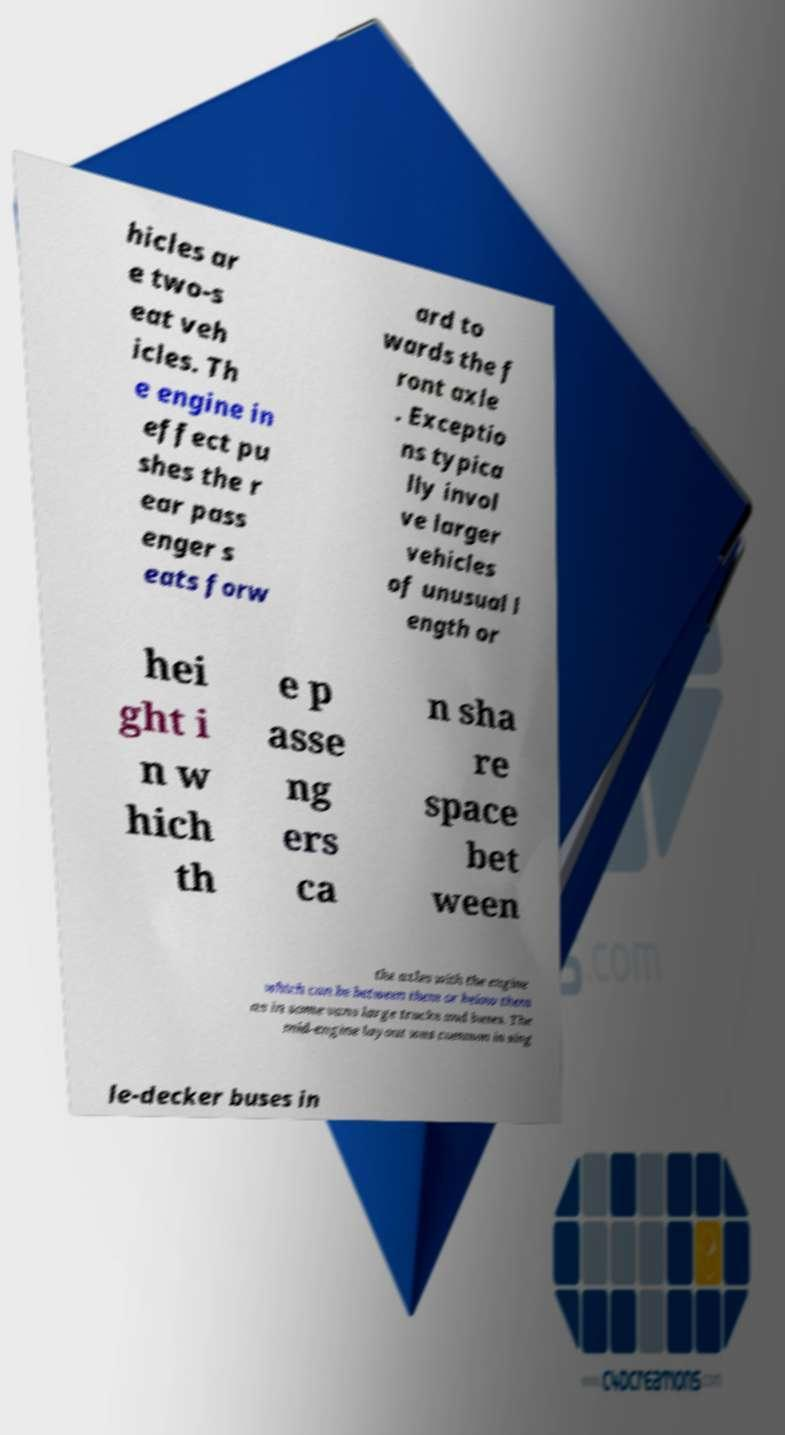Please identify and transcribe the text found in this image. hicles ar e two-s eat veh icles. Th e engine in effect pu shes the r ear pass enger s eats forw ard to wards the f ront axle . Exceptio ns typica lly invol ve larger vehicles of unusual l ength or hei ght i n w hich th e p asse ng ers ca n sha re space bet ween the axles with the engine which can be between them or below them as in some vans large trucks and buses. The mid-engine layout was common in sing le-decker buses in 